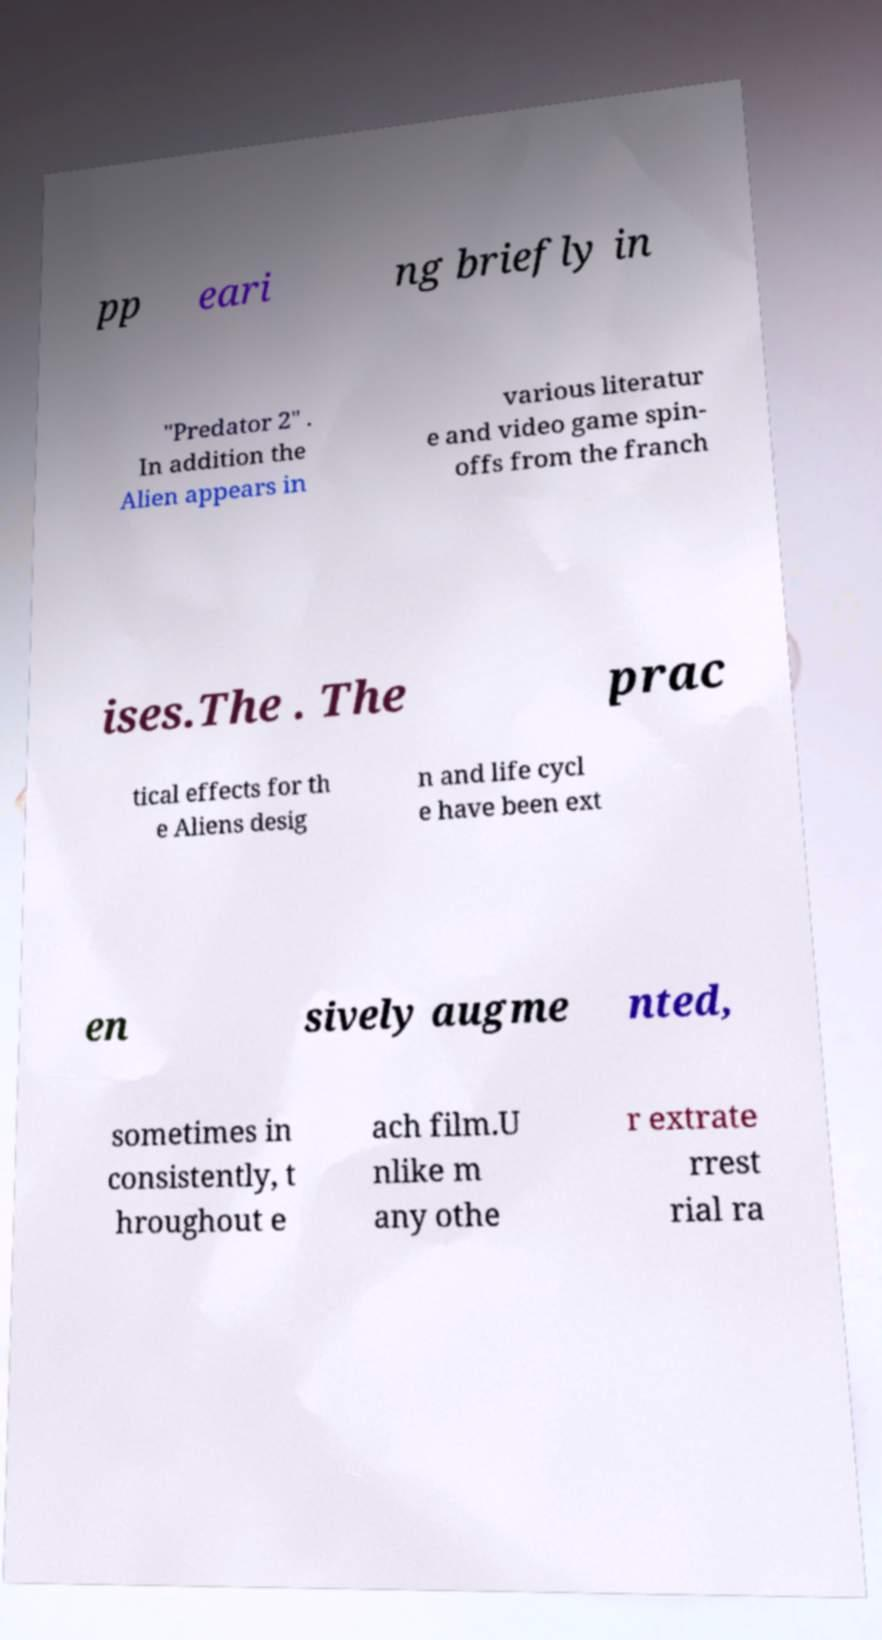Could you extract and type out the text from this image? pp eari ng briefly in "Predator 2" . In addition the Alien appears in various literatur e and video game spin- offs from the franch ises.The . The prac tical effects for th e Aliens desig n and life cycl e have been ext en sively augme nted, sometimes in consistently, t hroughout e ach film.U nlike m any othe r extrate rrest rial ra 